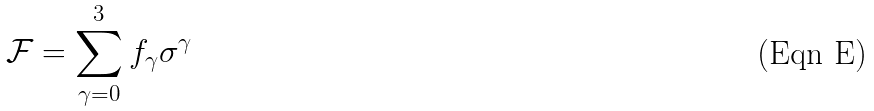<formula> <loc_0><loc_0><loc_500><loc_500>\mathcal { F } = \sum _ { \gamma = 0 } ^ { 3 } f _ { \gamma } \sigma ^ { \gamma }</formula> 